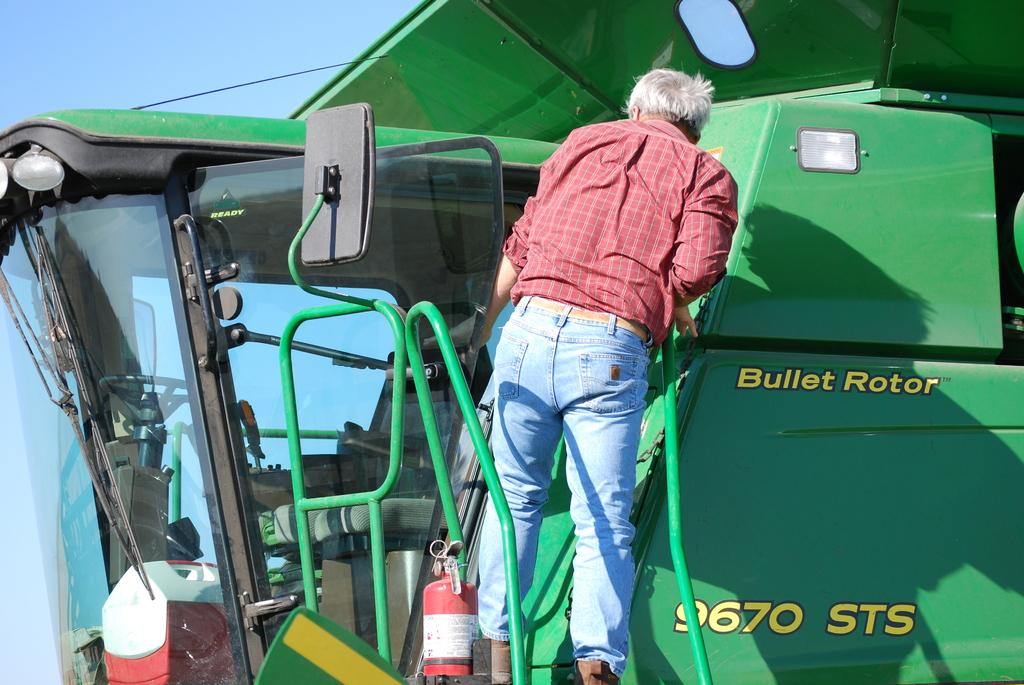Where was the image taken? The image is taken outdoors. What can be seen at the top of the image? The sky is visible at the top of the image. What is the main subject in the middle of the image? There is a vehicle in the middle of the image. What is the man in the image doing? A man is climbing on the vehicle. What verse is being recited by the goldfish in the image? There is no goldfish present in the image, and therefore no verse can be recited. 